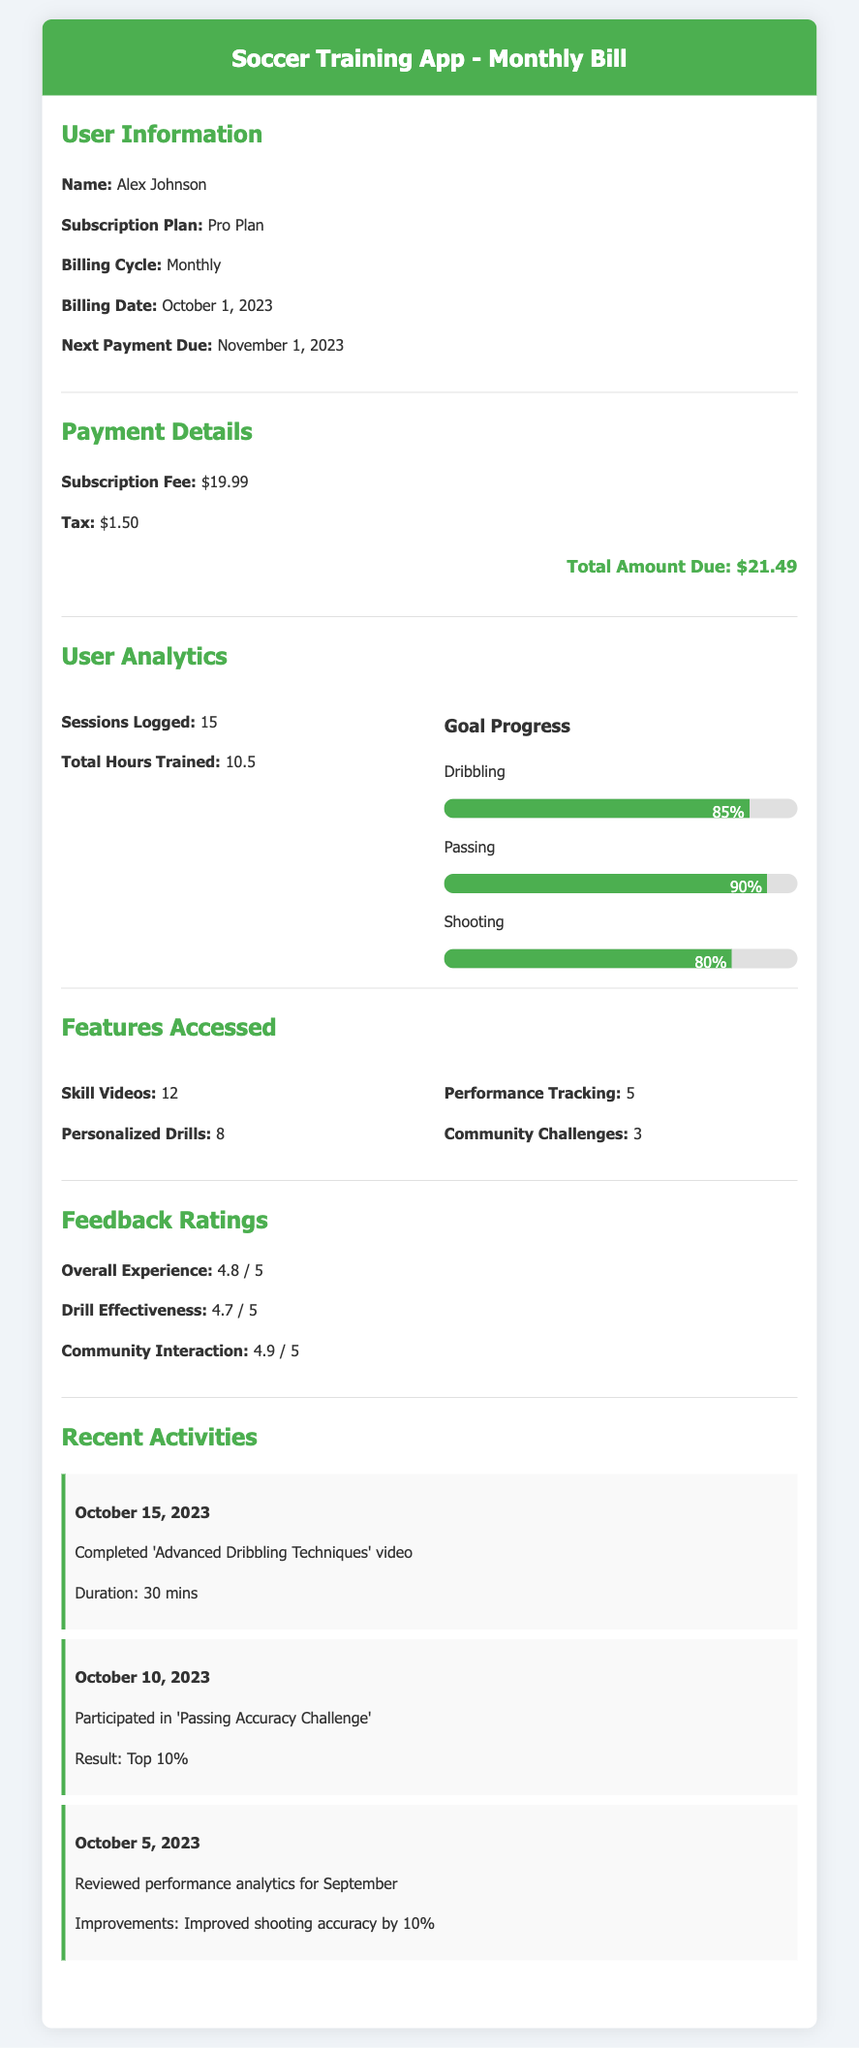What is the name of the user? The user's name is provided in the User Information section of the document.
Answer: Alex Johnson What is the billing date? The billing date indicates when the payment is due each month, mentioned in the User Information section.
Answer: October 1, 2023 What is the total amount due? The total amount due is the sum of the subscription fee and tax detailed in the Payment Details section.
Answer: $21.49 How many sessions were logged? The number of sessions logged is found in the User Analytics section, indicating usage of the app.
Answer: 15 What is the feedback rating for Overall Experience? The feedback rating for Overall Experience is listed in the Feedback Ratings section of the document.
Answer: 4.8 / 5 What percentage improvement was noted in shooting accuracy? The improvement in shooting accuracy is mentioned in the Recent Activities section related to performance analytics.
Answer: 10% Which feature was accessed the most? The most accessed feature according to the Features Accessed section is indicated by the highest number in that section.
Answer: Skill Videos When is the next payment due? The next payment due date is given in the User Information section, indicating future obligations.
Answer: November 1, 2023 